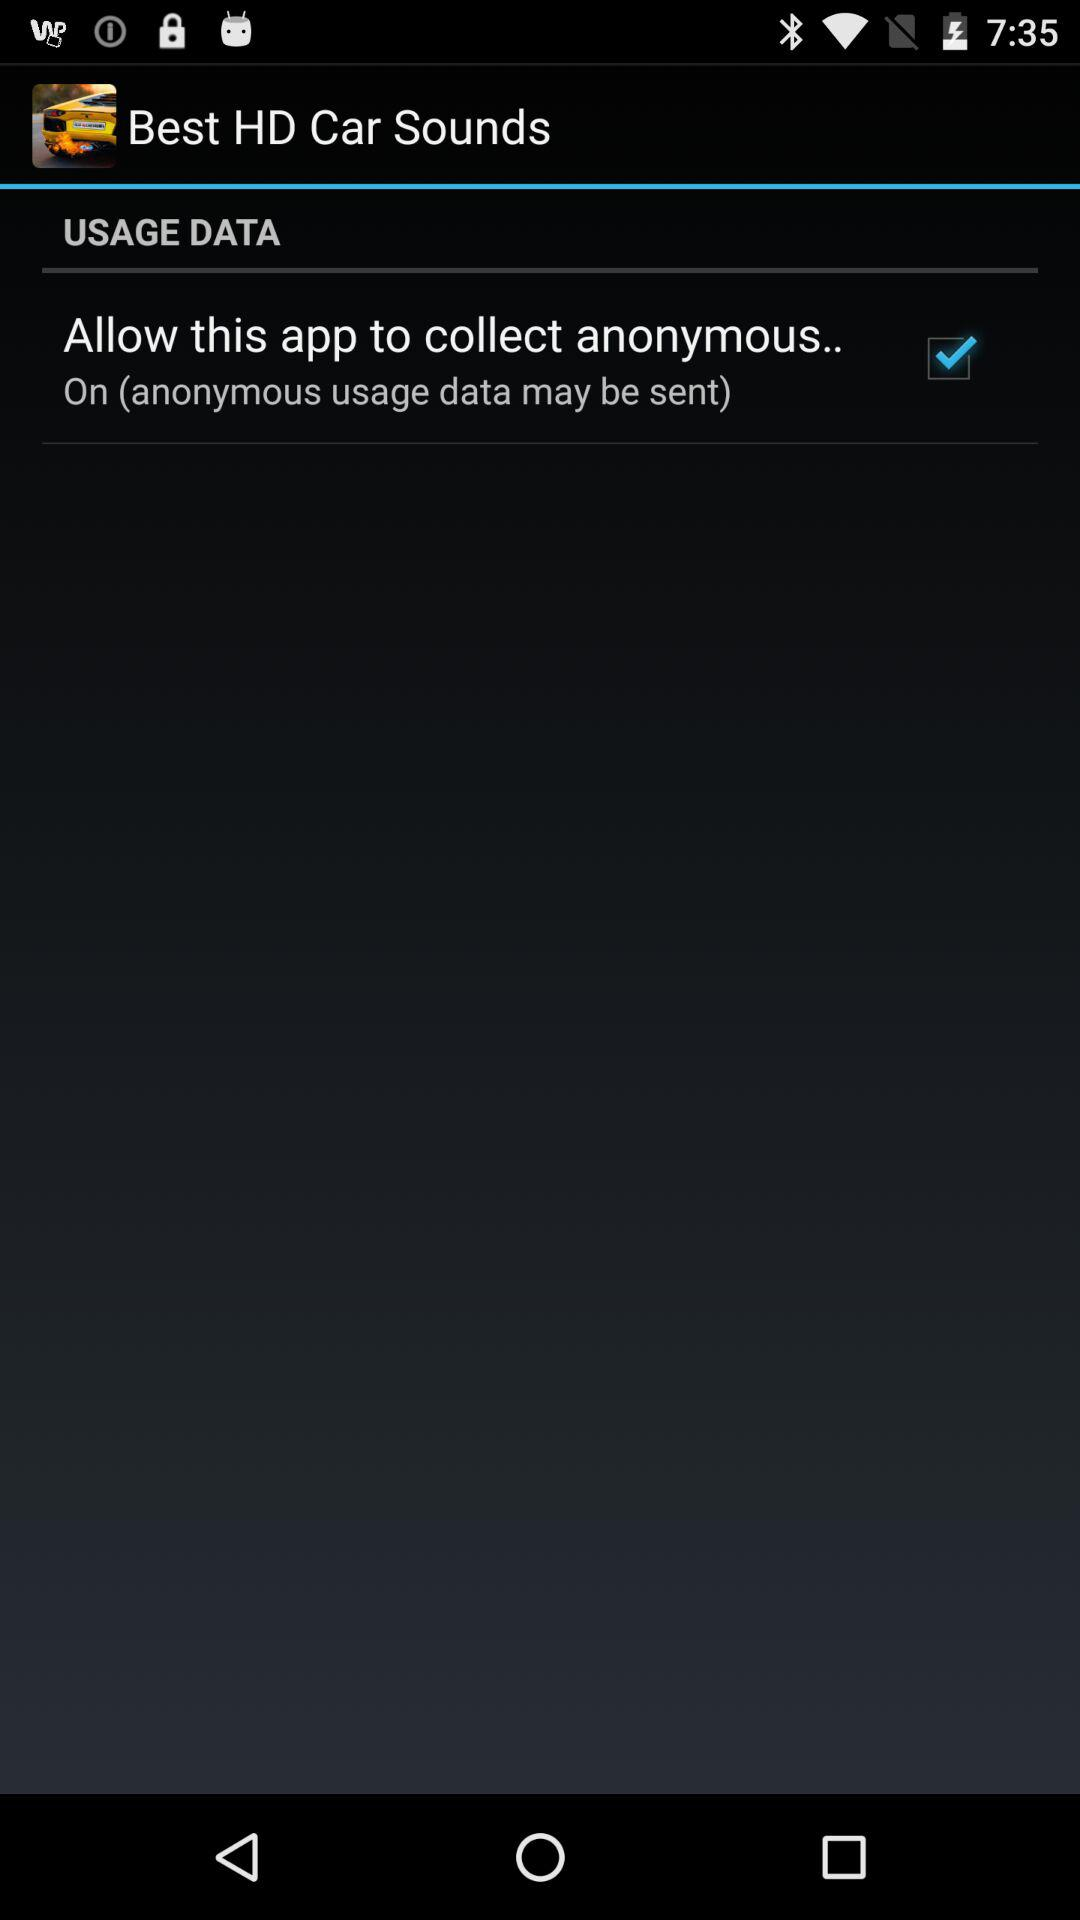What is the status of "Allow this app to collect anonymous.."? The status is "on". 